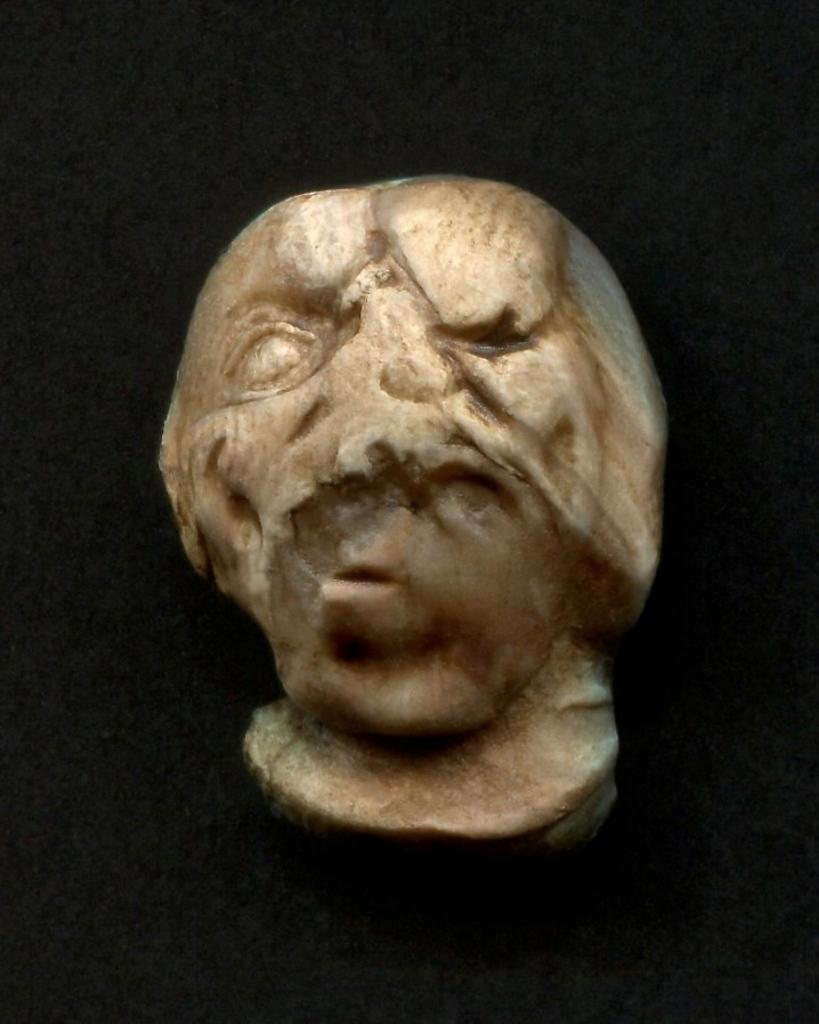What is the main subject in the center of the image? There is a stone in the center of the image. What can be seen in the background of the image? There is a wall in the background of the image. What attraction is the boy visiting in the image? There is no boy or attraction present in the image; it only features a stone and a wall. 